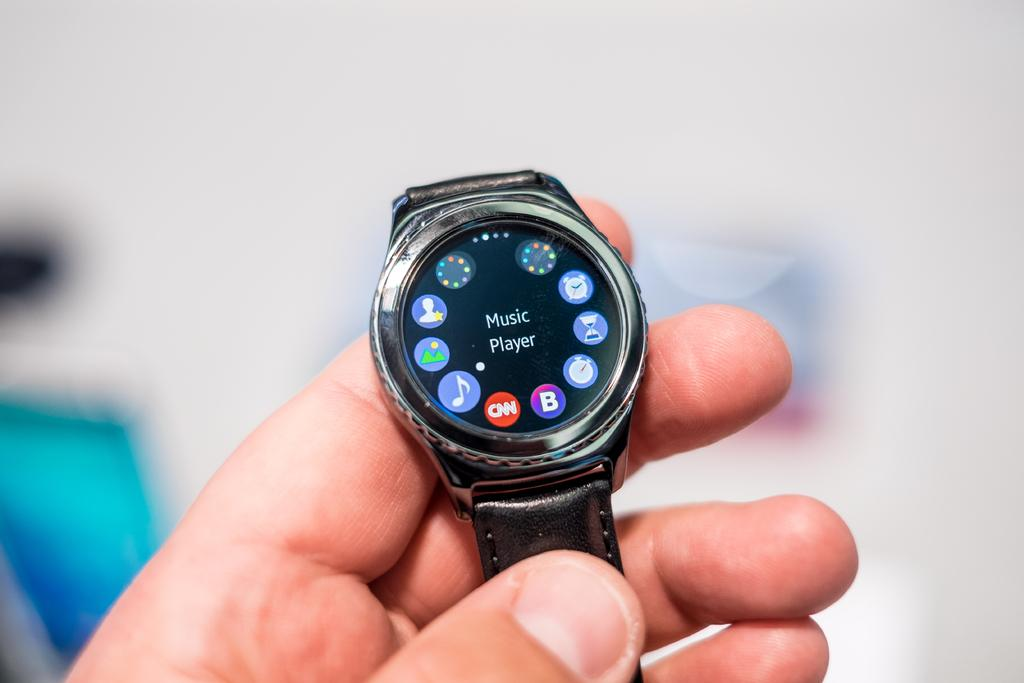Provide a one-sentence caption for the provided image. A smart watch with the words Music Player. 